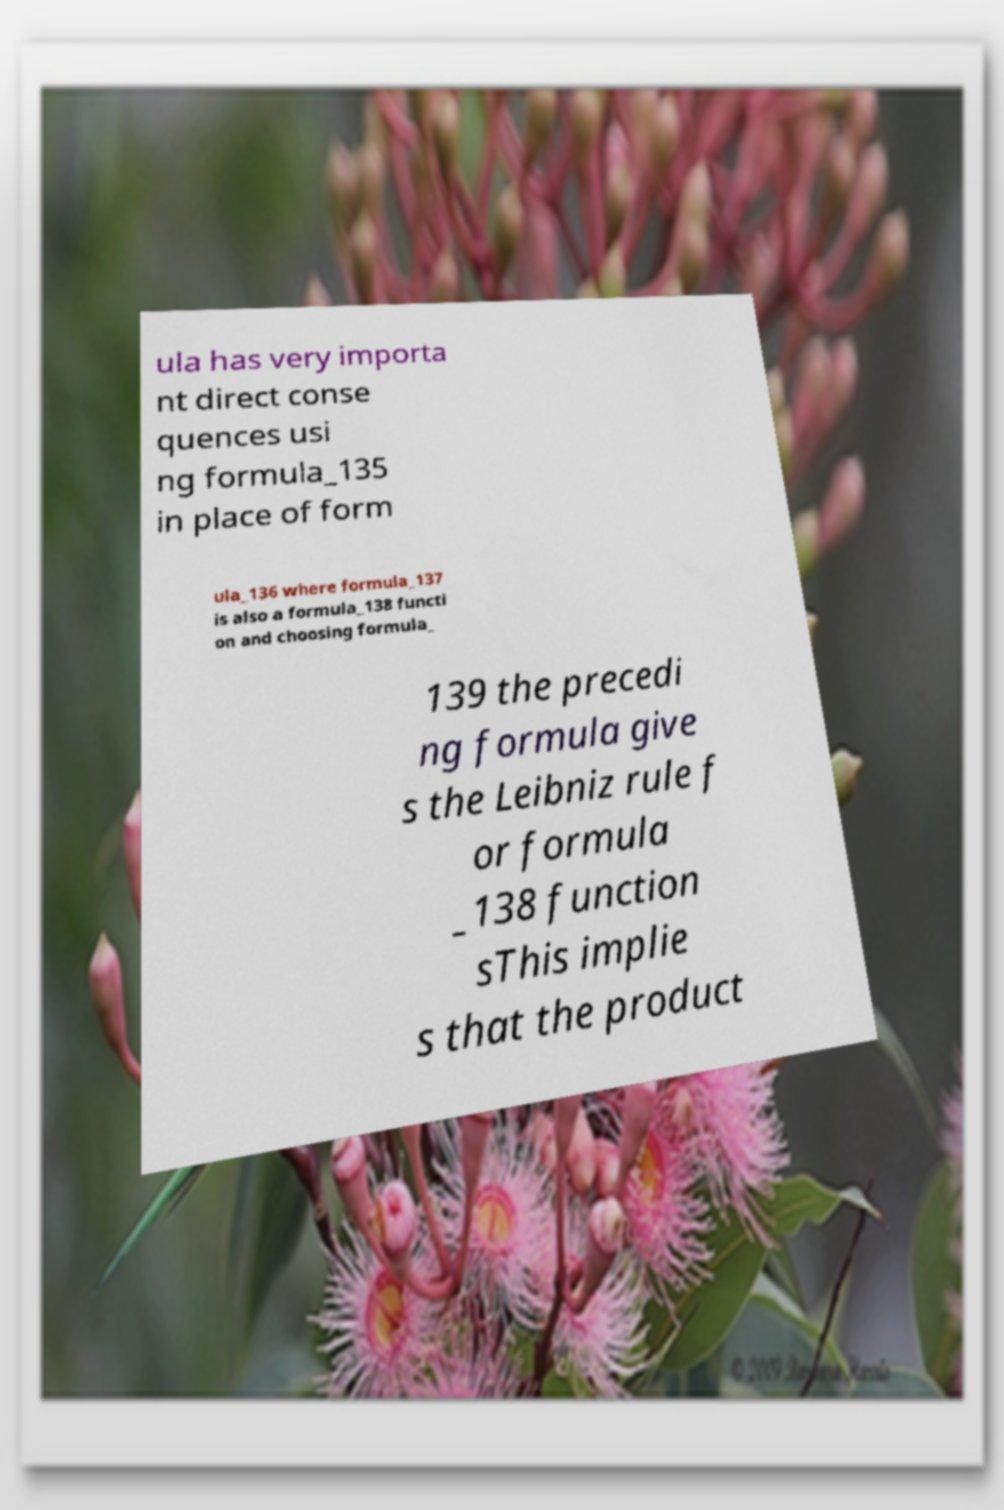There's text embedded in this image that I need extracted. Can you transcribe it verbatim? ula has very importa nt direct conse quences usi ng formula_135 in place of form ula_136 where formula_137 is also a formula_138 functi on and choosing formula_ 139 the precedi ng formula give s the Leibniz rule f or formula _138 function sThis implie s that the product 